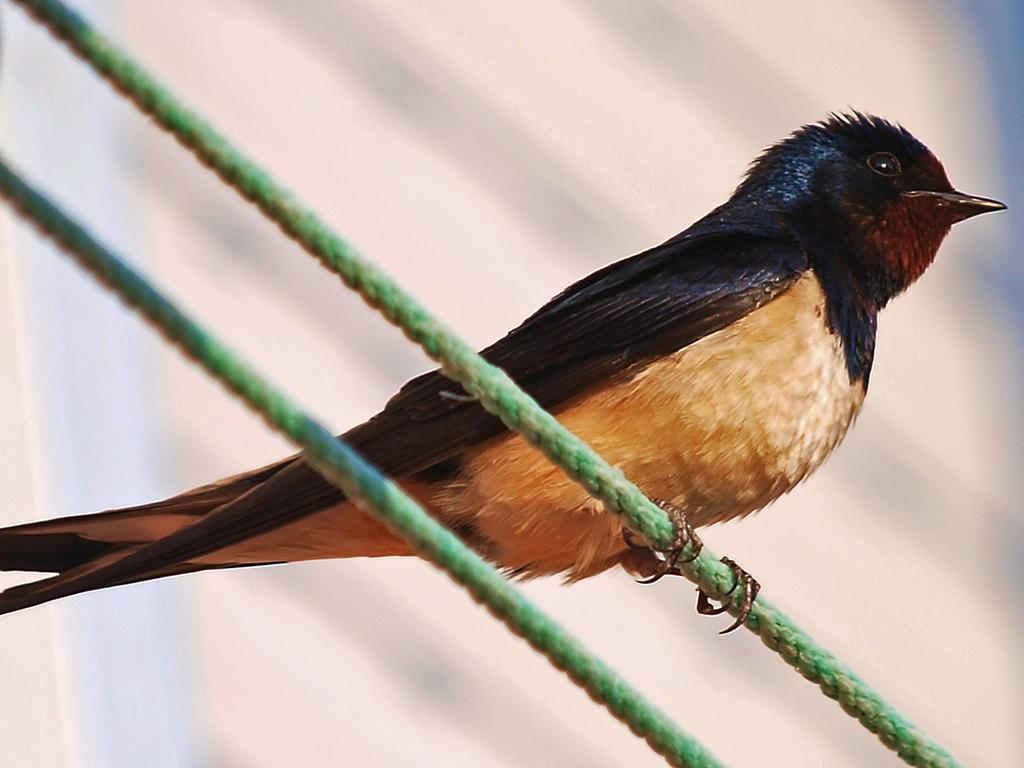What objects can be seen in the image? There are ropes in the image. Are there any living creatures present in the image? Yes, there is a bird in the image. What is the bird doing in the image? The bird is on a rope. What type of business is the bird conducting in the image? There is no indication of a business in the image; it simply shows a bird on a rope. 